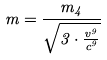<formula> <loc_0><loc_0><loc_500><loc_500>m = \frac { m _ { 4 } } { \sqrt { 3 \cdot \frac { v ^ { 9 } } { c ^ { 9 } } } }</formula> 